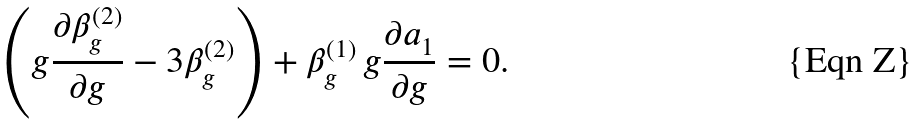Convert formula to latex. <formula><loc_0><loc_0><loc_500><loc_500>\left ( g \frac { \partial \beta _ { g } ^ { ( 2 ) } } { \partial g } - 3 \beta _ { g } ^ { ( 2 ) } \right ) + \beta _ { g } ^ { ( 1 ) } \, g \frac { \partial a _ { 1 } } { \partial g } = 0 .</formula> 